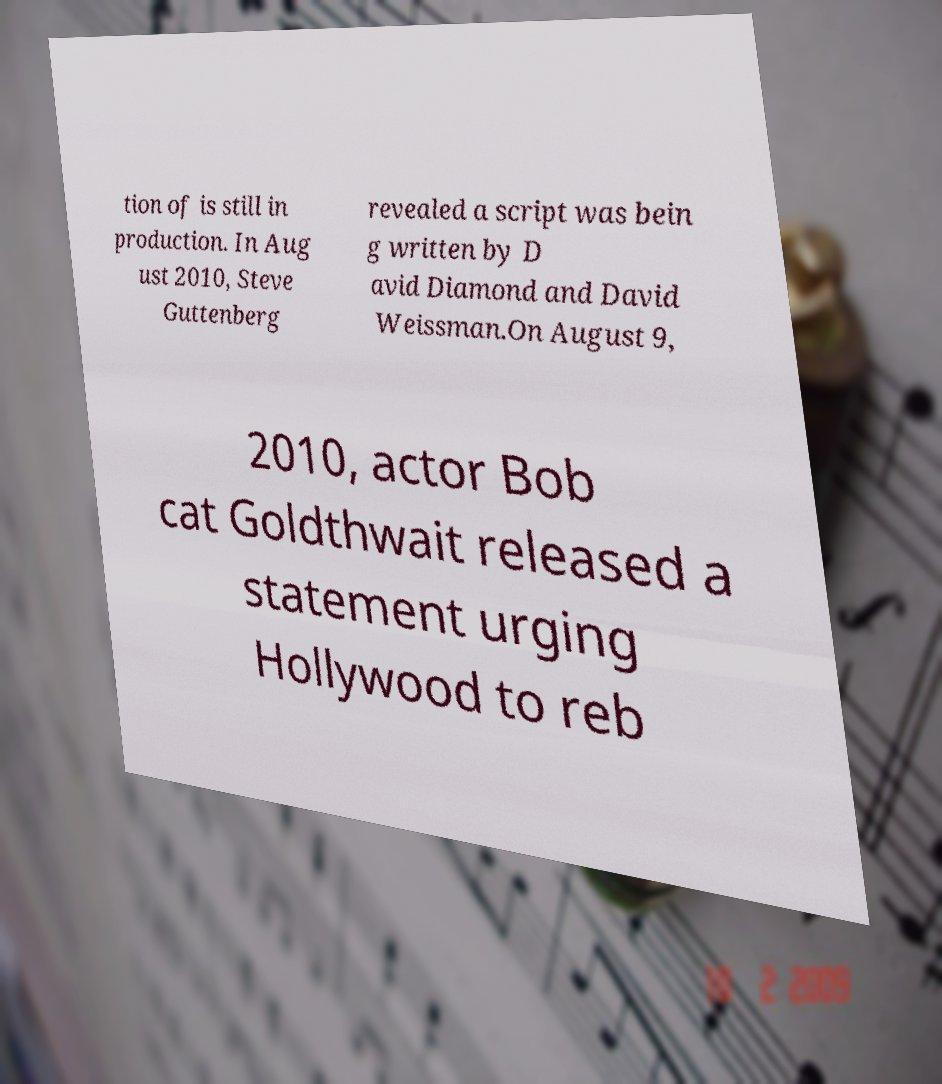Could you extract and type out the text from this image? tion of is still in production. In Aug ust 2010, Steve Guttenberg revealed a script was bein g written by D avid Diamond and David Weissman.On August 9, 2010, actor Bob cat Goldthwait released a statement urging Hollywood to reb 